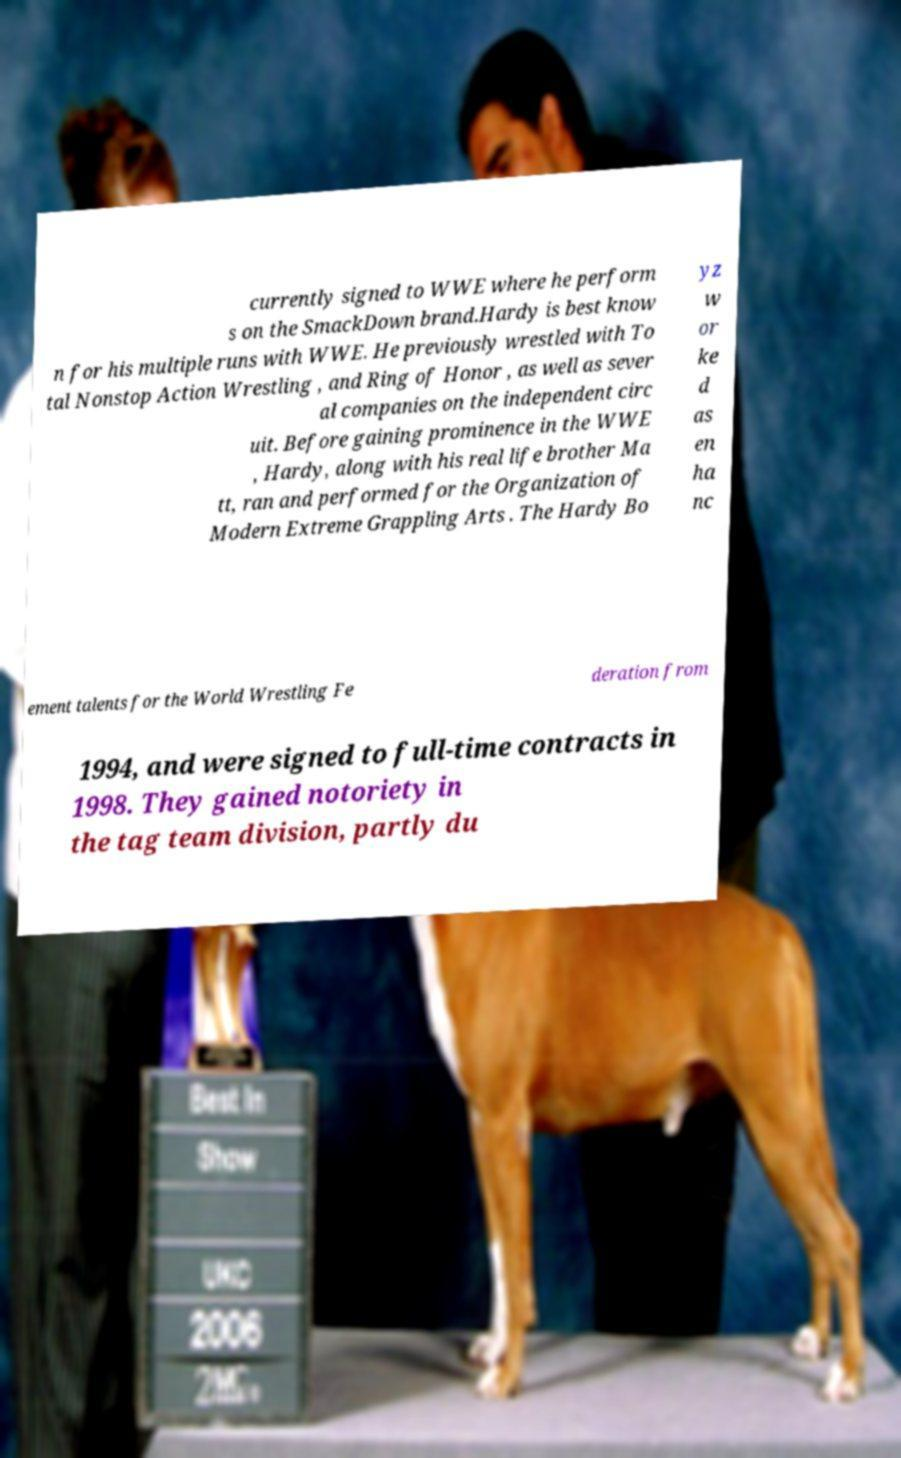What messages or text are displayed in this image? I need them in a readable, typed format. currently signed to WWE where he perform s on the SmackDown brand.Hardy is best know n for his multiple runs with WWE. He previously wrestled with To tal Nonstop Action Wrestling , and Ring of Honor , as well as sever al companies on the independent circ uit. Before gaining prominence in the WWE , Hardy, along with his real life brother Ma tt, ran and performed for the Organization of Modern Extreme Grappling Arts . The Hardy Bo yz w or ke d as en ha nc ement talents for the World Wrestling Fe deration from 1994, and were signed to full-time contracts in 1998. They gained notoriety in the tag team division, partly du 